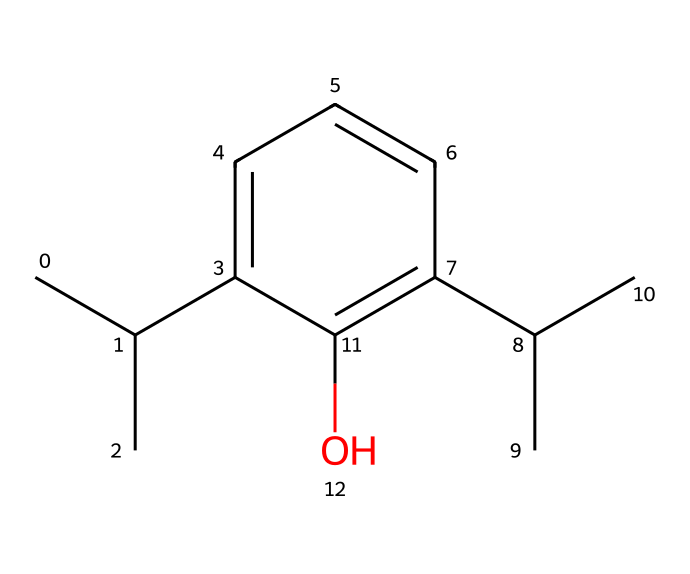What is the molecular formula of propofol? Analyzing the SMILES representation, we can identify the types and counts of atoms present. 'CC(C)' indicates three carbon atoms in a branched chain, and 'c1cccc(C(C)C)c1' shows five aromatic carbon atoms with additional carbon branches. The 'O' at the end indicates one oxygen atom. Thus, the molecular formula can be derived as C12H18O.
Answer: C12H18O How many carbon atoms are present in this structure? Counting the carbon atoms from the SMILES string, we see 'CC(C)' contributes three, and 'c1cccc(C(C)C)c1' contributes five more carbons in the aromatic system along with the two from the branches. This gives a total of twelve carbon atoms.
Answer: 12 What type of chemical bonding is predominant in propofol's structure? The structure consists primarily of carbon and hydrogen atoms forming covalent bonds, especially within the carbon chain and aromatic ring. Aromatic rings typically have delocalized pi bonds, which are a characteristic feature of covalent bonding in organic compounds.
Answer: covalent Is propofol a polar or non-polar molecule? Evaluating the functional groups, the presence of the hydroxyl group (O) indicates some polarity. However, the majority of the molecule consists of carbon and hydrogen, which tend to be non-polar. The overall structure leans towards being non-polar due to the larger hydrophobic carbon chains.
Answer: non-polar What functional group is present in propofol? In the structure, the 'O' in the hydroxyl (alcohol) group (-OH) signifies the presence of a functional group. This is crucial for determining its chemical properties and behavior as an anesthetic.
Answer: hydroxyl What is the significance of the hydroxyl group in the molecular structure of propofol? The hydroxyl group enhances the solubility of propofol in biological fluids, facilitating its administration as an injectable anesthetic. It also plays a role in the drug's pharmacodynamics, influencing how the molecule interacts with receptors in the body.
Answer: solubility 